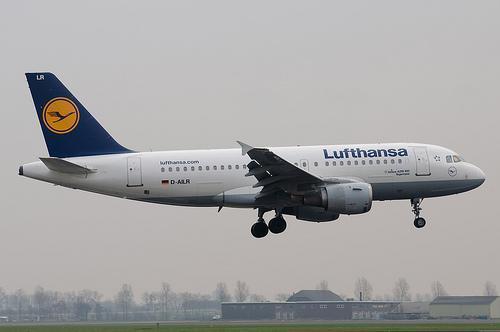How many wheels are on the plane?
Give a very brief answer. 3. 